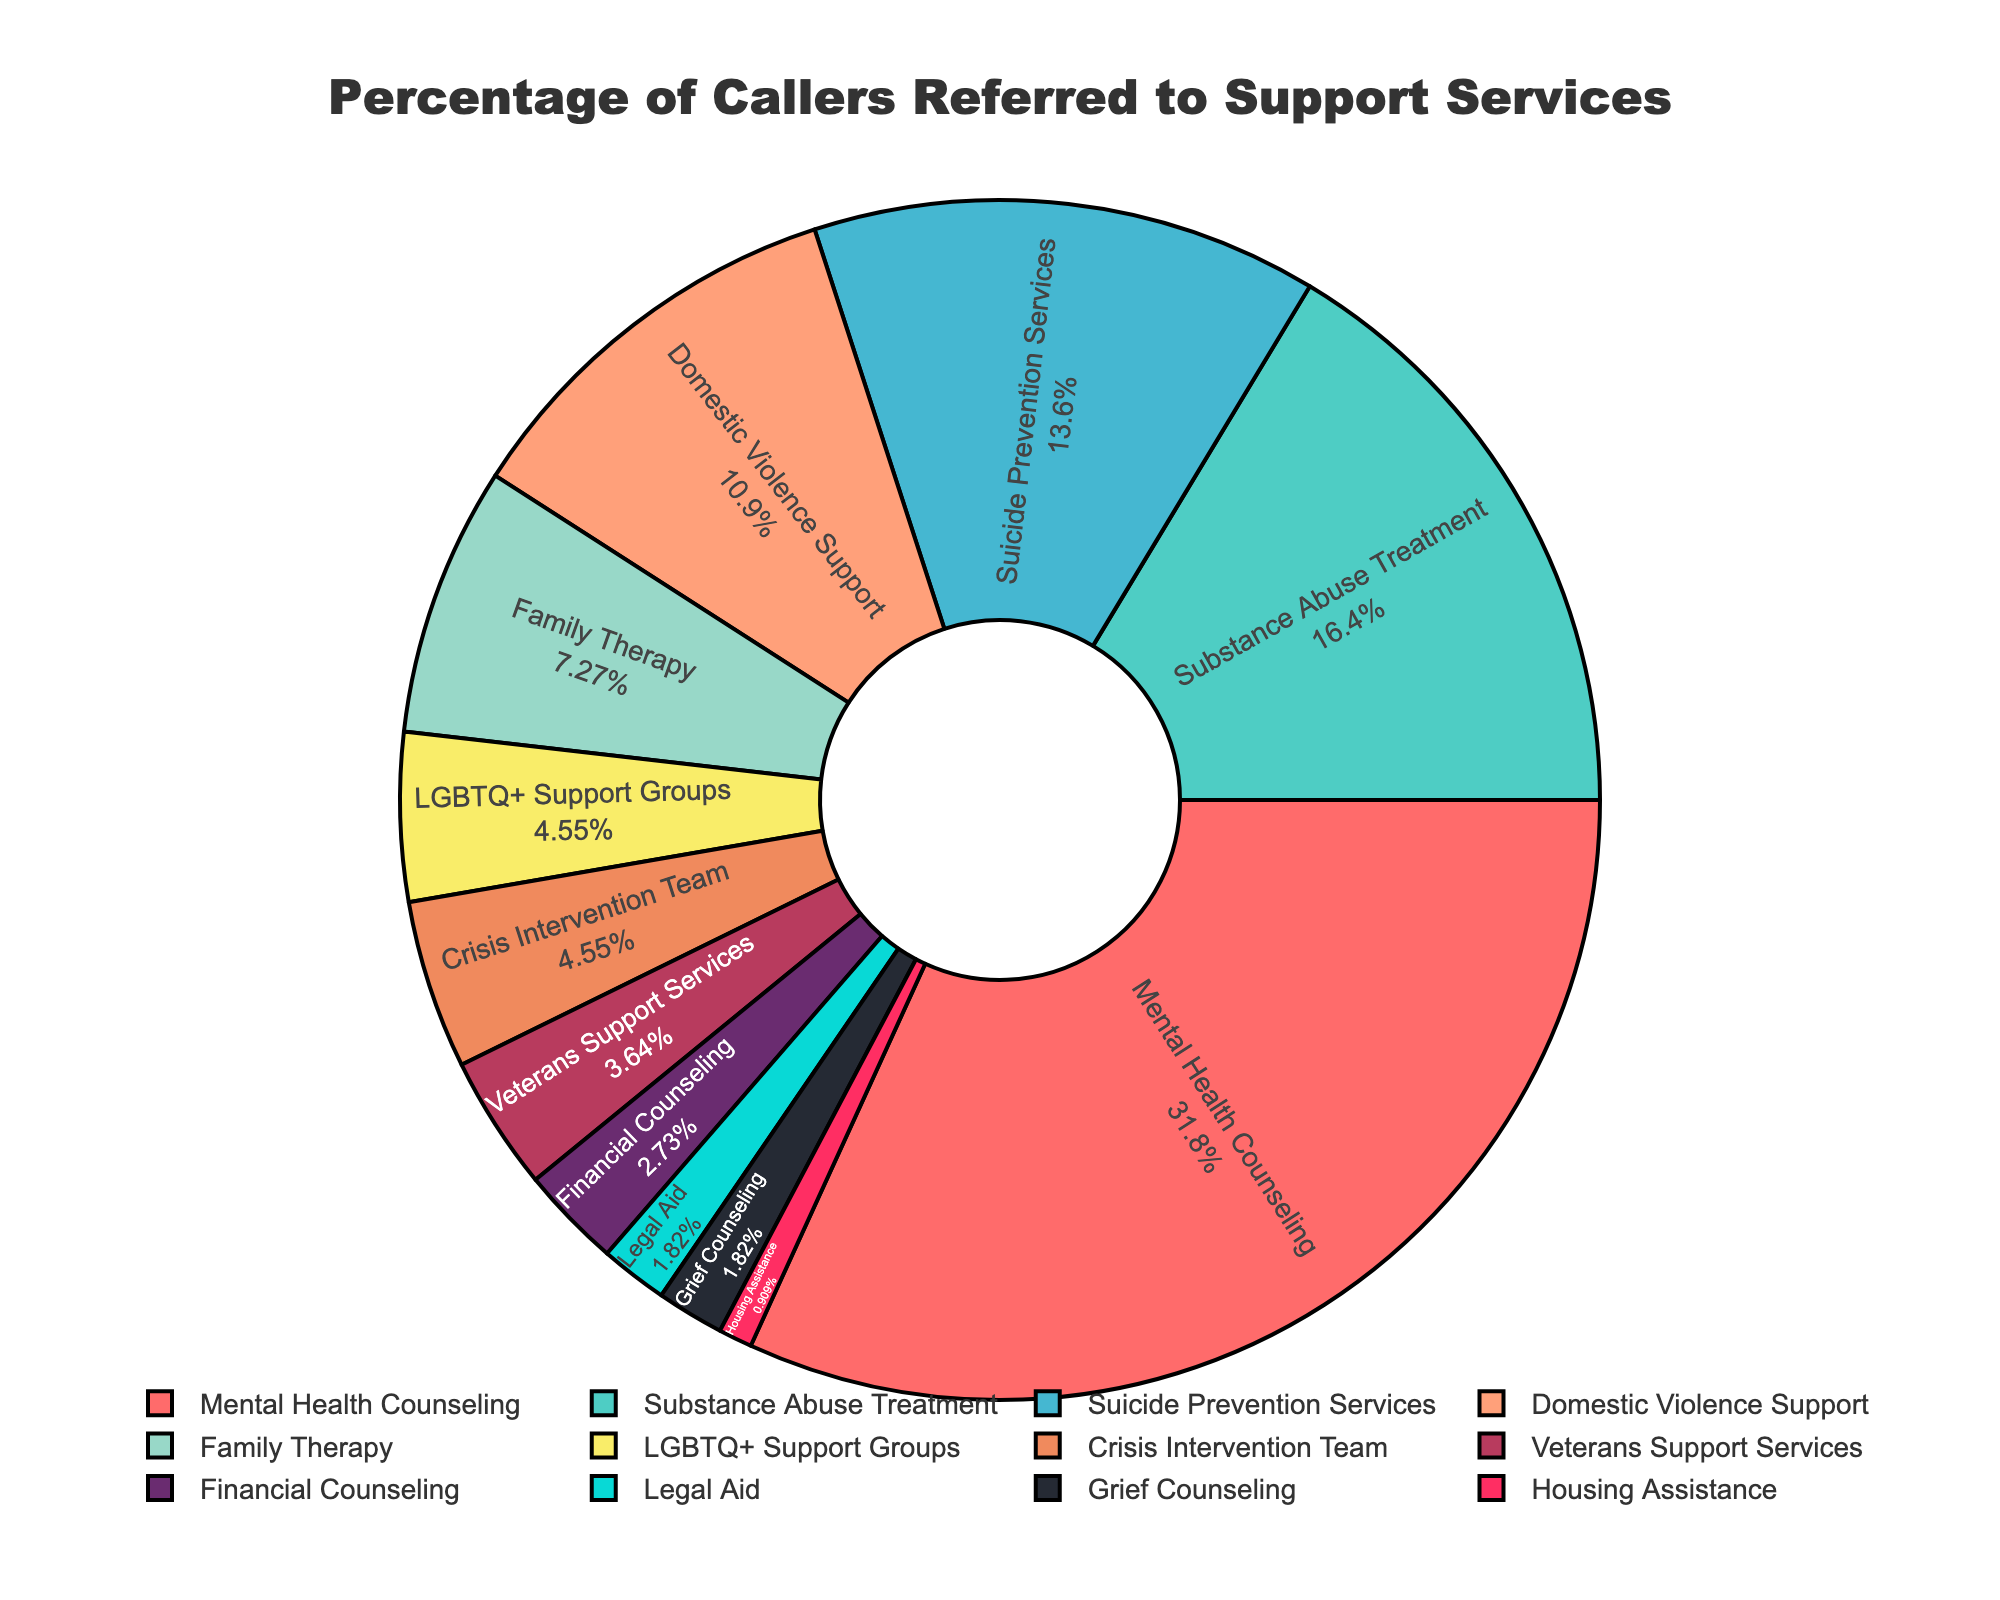What percentage of callers were referred to Mental Health Counseling? The pie chart highlights each referral service with its corresponding percentage. Mental Health Counseling shows 35%.
Answer: 35% Which service received the second-highest number of referrals? The pie chart arranges services in descending order of percentage. The second largest segment following Mental Health Counseling (35%) is Substance Abuse Treatment at 18%.
Answer: Substance Abuse Treatment How much more frequently were callers referred to Domestic Violence Support compared to Legal Aid? Find percentages of both services: Domestic Violence Support (12%) and Legal Aid (2%). Subtract Legal Aid from Domestic Violence Support: 12% - 2% = 10%.
Answer: 10% What is the combined percentage of callers referred to Family Therapy and LGBTQ+ Support Groups? Add the percentages of Family Therapy (8%) and LGBTQ+ Support Groups (5%): 8% + 5% = 13%.
Answer: 13% Which service shares the same percentage of referrals as Crisis Intervention Team? Both Crisis Intervention Team and LGBTQ+ Support Groups have segments with 5%.
Answer: LGBTQ+ Support Groups What percentage of callers were referred to services providing financial or legal aid? Sum the percentages for Financial Counseling (3%) and Legal Aid (2%): 3% + 2% = 5%.
Answer: 5% What is the sum percentage of callers referred to Veteran Support Services, Legal Aid, and Grief Counseling? Add the percentages for Veterans Support Services (4%), Legal Aid (2%), and Grief Counseling (2%): 4% + 2% + 2% = 8%.
Answer: 8% Which services were referred to less frequently than Family Therapy? Family Therapy is at 8%. All services less frequently referred are LGBTQ+ Support Groups (5%), Veterans Support Services (4%), Financial Counseling (3%), Legal Aid (2%), Housing Assistance (1%), and Grief Counseling (2%).
Answer: LGBTQ+ Support Groups, Veterans Support Services, Financial Counseling, Legal Aid, Housing Assistance, Grief Counseling 